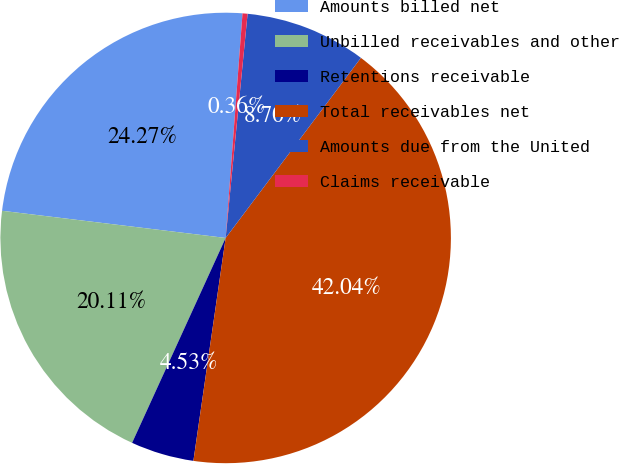<chart> <loc_0><loc_0><loc_500><loc_500><pie_chart><fcel>Amounts billed net<fcel>Unbilled receivables and other<fcel>Retentions receivable<fcel>Total receivables net<fcel>Amounts due from the United<fcel>Claims receivable<nl><fcel>24.27%<fcel>20.11%<fcel>4.53%<fcel>42.04%<fcel>8.7%<fcel>0.36%<nl></chart> 